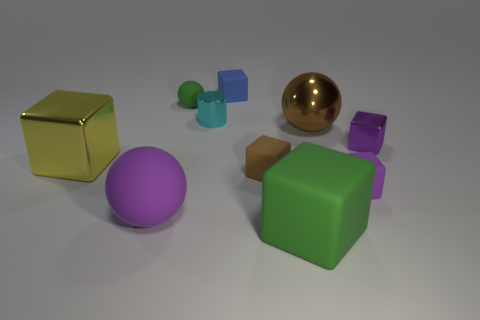The purple matte cube has what size?
Make the answer very short. Small. Are there the same number of purple shiny cubes to the left of the purple matte ball and small matte blocks?
Offer a terse response. No. What number of other things are the same color as the cylinder?
Give a very brief answer. 0. There is a metal object that is both in front of the brown metallic sphere and to the right of the big green rubber block; what color is it?
Offer a very short reply. Purple. What is the size of the green matte object right of the green rubber object that is behind the purple rubber thing that is on the left side of the big green object?
Make the answer very short. Large. What number of things are big shiny objects that are right of the brown rubber object or purple things that are behind the big purple matte ball?
Make the answer very short. 3. There is a tiny cyan object; what shape is it?
Provide a succinct answer. Cylinder. How many other things are made of the same material as the cyan thing?
Ensure brevity in your answer.  3. What is the size of the green object that is the same shape as the big purple object?
Ensure brevity in your answer.  Small. There is a large object that is behind the large yellow metallic block that is on the left side of the large sphere right of the green sphere; what is its material?
Your answer should be compact. Metal. 